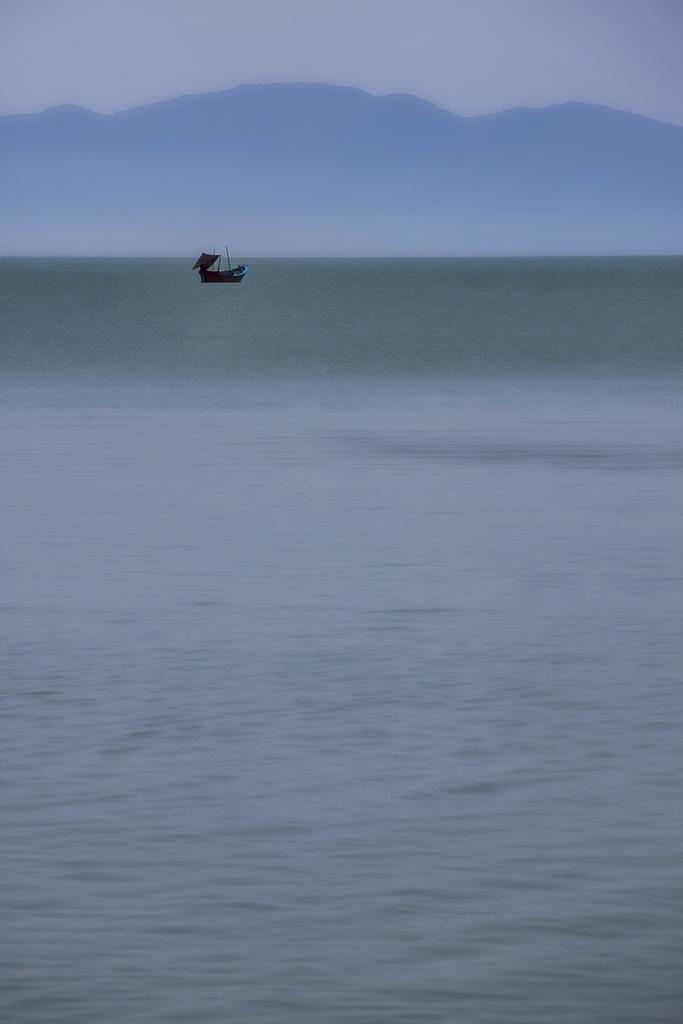In one or two sentences, can you explain what this image depicts? In this image there is water and we can see a boat on the water. In the background there are hills and sky. 